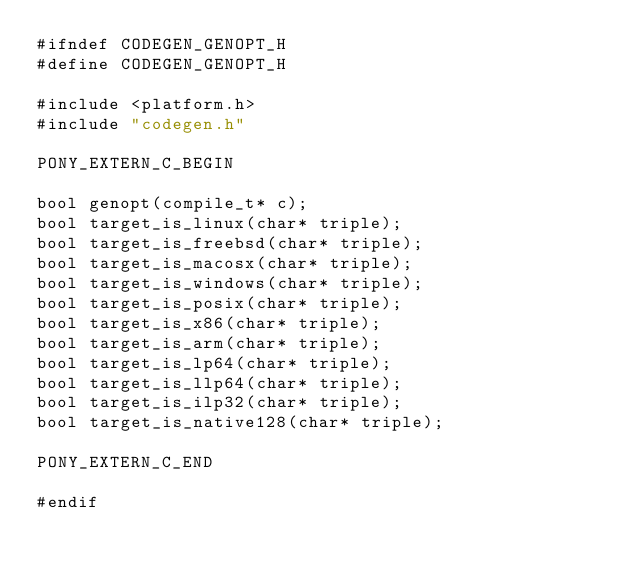<code> <loc_0><loc_0><loc_500><loc_500><_C_>#ifndef CODEGEN_GENOPT_H
#define CODEGEN_GENOPT_H

#include <platform.h>
#include "codegen.h"

PONY_EXTERN_C_BEGIN

bool genopt(compile_t* c);
bool target_is_linux(char* triple);
bool target_is_freebsd(char* triple);
bool target_is_macosx(char* triple);
bool target_is_windows(char* triple);
bool target_is_posix(char* triple);
bool target_is_x86(char* triple);
bool target_is_arm(char* triple);
bool target_is_lp64(char* triple);
bool target_is_llp64(char* triple);
bool target_is_ilp32(char* triple);
bool target_is_native128(char* triple);

PONY_EXTERN_C_END

#endif
</code> 